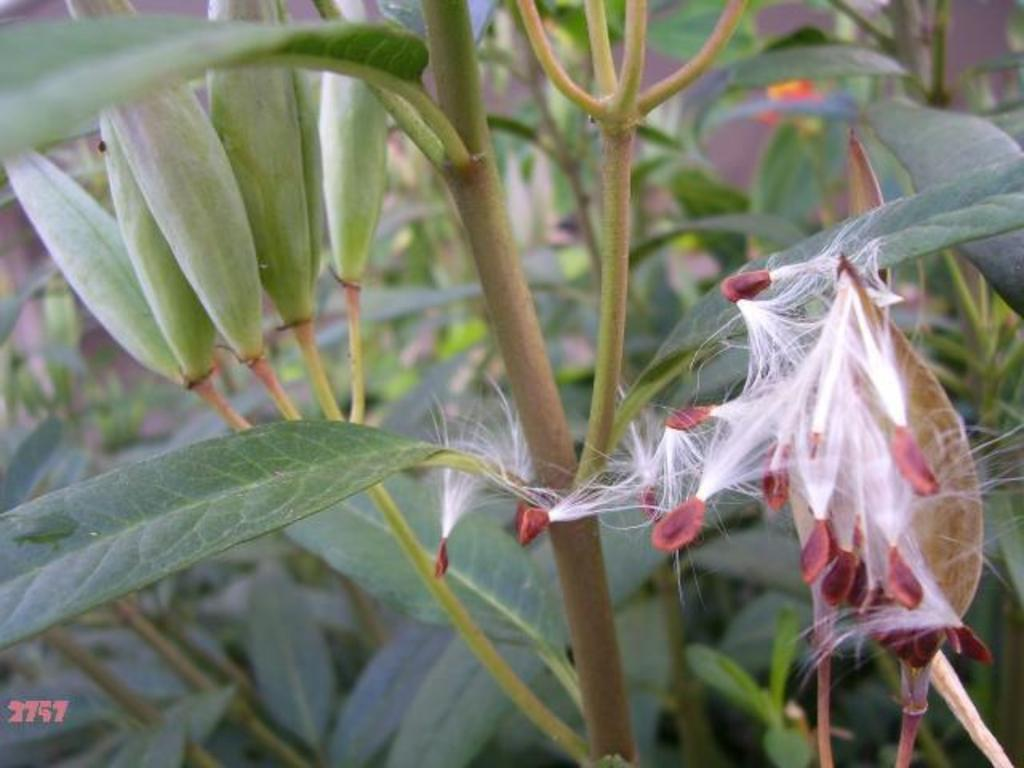What type of plants are in the foreground of the image? There are weed cotton plants in the foreground of the image. What can be seen in the background of the image? There are plants in the background of the image. What type of rose is depicted in the image? There is no rose present in the image; it features weed cotton plants in the foreground and plants in the background. 